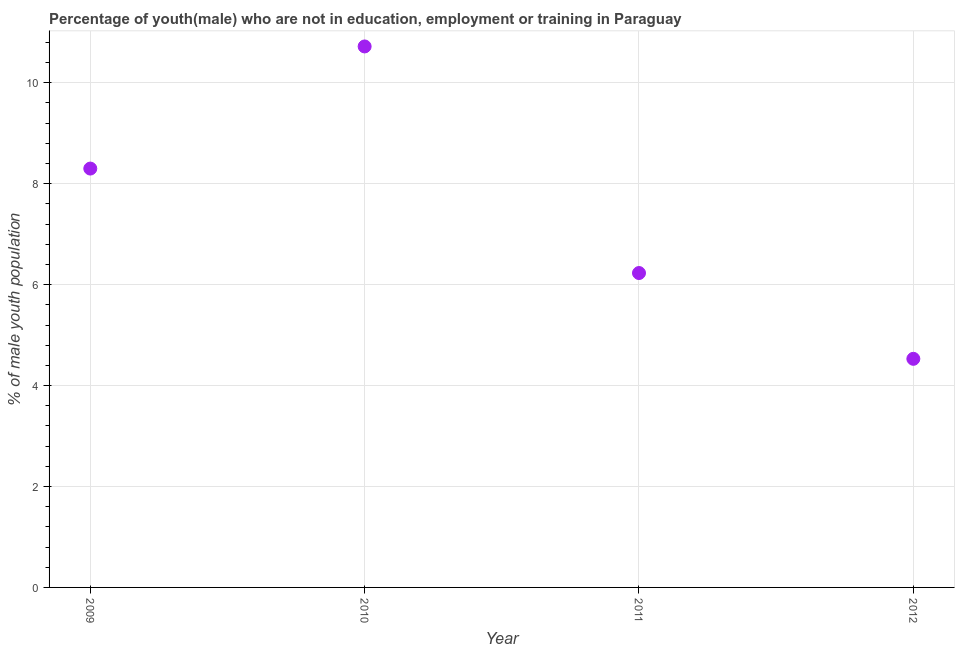What is the unemployed male youth population in 2012?
Offer a very short reply. 4.53. Across all years, what is the maximum unemployed male youth population?
Your response must be concise. 10.72. Across all years, what is the minimum unemployed male youth population?
Ensure brevity in your answer.  4.53. In which year was the unemployed male youth population maximum?
Provide a short and direct response. 2010. What is the sum of the unemployed male youth population?
Ensure brevity in your answer.  29.78. What is the difference between the unemployed male youth population in 2009 and 2012?
Give a very brief answer. 3.77. What is the average unemployed male youth population per year?
Provide a short and direct response. 7.45. What is the median unemployed male youth population?
Keep it short and to the point. 7.27. In how many years, is the unemployed male youth population greater than 0.4 %?
Give a very brief answer. 4. Do a majority of the years between 2012 and 2011 (inclusive) have unemployed male youth population greater than 5.2 %?
Give a very brief answer. No. What is the ratio of the unemployed male youth population in 2009 to that in 2010?
Your answer should be very brief. 0.77. Is the unemployed male youth population in 2009 less than that in 2012?
Provide a succinct answer. No. What is the difference between the highest and the second highest unemployed male youth population?
Make the answer very short. 2.42. What is the difference between the highest and the lowest unemployed male youth population?
Keep it short and to the point. 6.19. How many dotlines are there?
Your answer should be very brief. 1. What is the difference between two consecutive major ticks on the Y-axis?
Offer a very short reply. 2. Are the values on the major ticks of Y-axis written in scientific E-notation?
Your answer should be compact. No. Does the graph contain any zero values?
Offer a terse response. No. What is the title of the graph?
Your answer should be very brief. Percentage of youth(male) who are not in education, employment or training in Paraguay. What is the label or title of the X-axis?
Provide a short and direct response. Year. What is the label or title of the Y-axis?
Offer a terse response. % of male youth population. What is the % of male youth population in 2009?
Keep it short and to the point. 8.3. What is the % of male youth population in 2010?
Give a very brief answer. 10.72. What is the % of male youth population in 2011?
Give a very brief answer. 6.23. What is the % of male youth population in 2012?
Make the answer very short. 4.53. What is the difference between the % of male youth population in 2009 and 2010?
Keep it short and to the point. -2.42. What is the difference between the % of male youth population in 2009 and 2011?
Your answer should be compact. 2.07. What is the difference between the % of male youth population in 2009 and 2012?
Make the answer very short. 3.77. What is the difference between the % of male youth population in 2010 and 2011?
Provide a succinct answer. 4.49. What is the difference between the % of male youth population in 2010 and 2012?
Ensure brevity in your answer.  6.19. What is the difference between the % of male youth population in 2011 and 2012?
Your answer should be very brief. 1.7. What is the ratio of the % of male youth population in 2009 to that in 2010?
Offer a terse response. 0.77. What is the ratio of the % of male youth population in 2009 to that in 2011?
Offer a very short reply. 1.33. What is the ratio of the % of male youth population in 2009 to that in 2012?
Your response must be concise. 1.83. What is the ratio of the % of male youth population in 2010 to that in 2011?
Your response must be concise. 1.72. What is the ratio of the % of male youth population in 2010 to that in 2012?
Offer a very short reply. 2.37. What is the ratio of the % of male youth population in 2011 to that in 2012?
Ensure brevity in your answer.  1.38. 